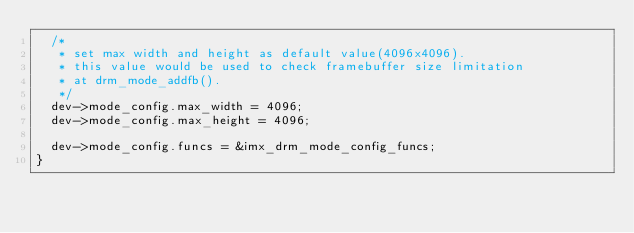Convert code to text. <code><loc_0><loc_0><loc_500><loc_500><_C_>	/*
	 * set max width and height as default value(4096x4096).
	 * this value would be used to check framebuffer size limitation
	 * at drm_mode_addfb().
	 */
	dev->mode_config.max_width = 4096;
	dev->mode_config.max_height = 4096;

	dev->mode_config.funcs = &imx_drm_mode_config_funcs;
}
</code> 